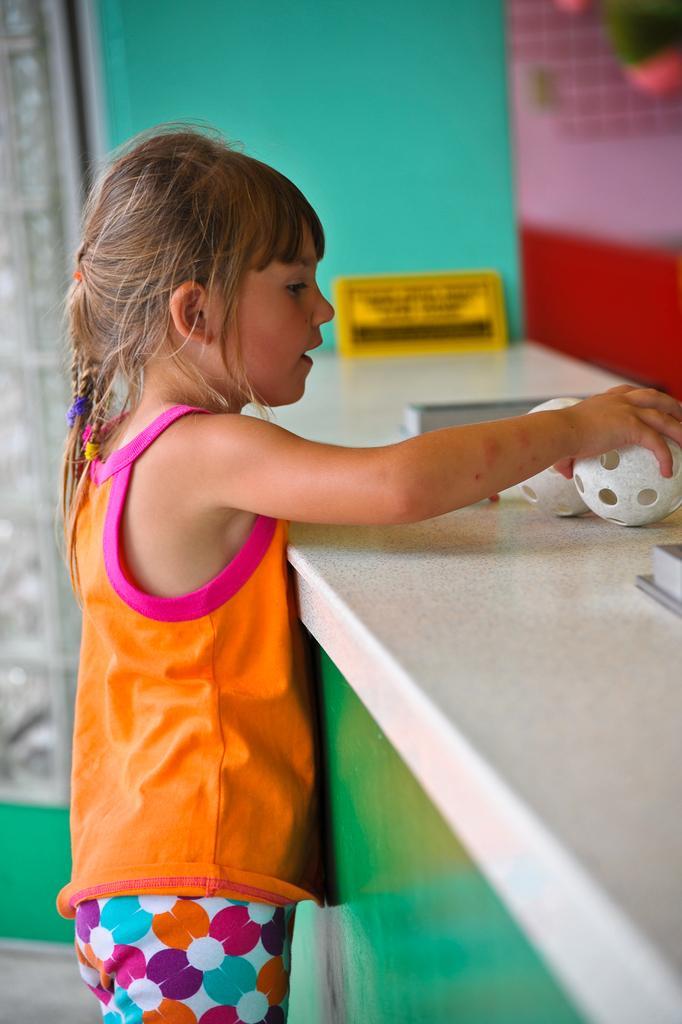Can you describe this image briefly? In this picture I can see a girl holding a ball on the countertop and I can see a small board with some text and I can see another ball on the side. 